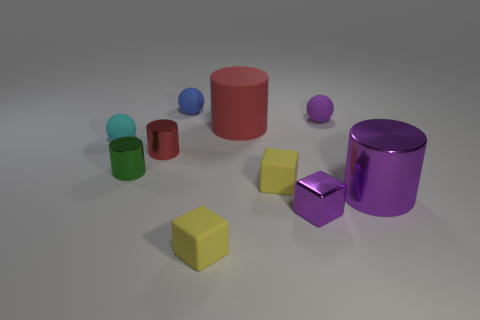Subtract all gray cylinders. Subtract all cyan blocks. How many cylinders are left? 4 Subtract all cylinders. How many objects are left? 6 Add 2 green metallic cylinders. How many green metallic cylinders are left? 3 Add 1 purple blocks. How many purple blocks exist? 2 Subtract 0 gray cylinders. How many objects are left? 10 Subtract all tiny purple matte objects. Subtract all small purple matte spheres. How many objects are left? 8 